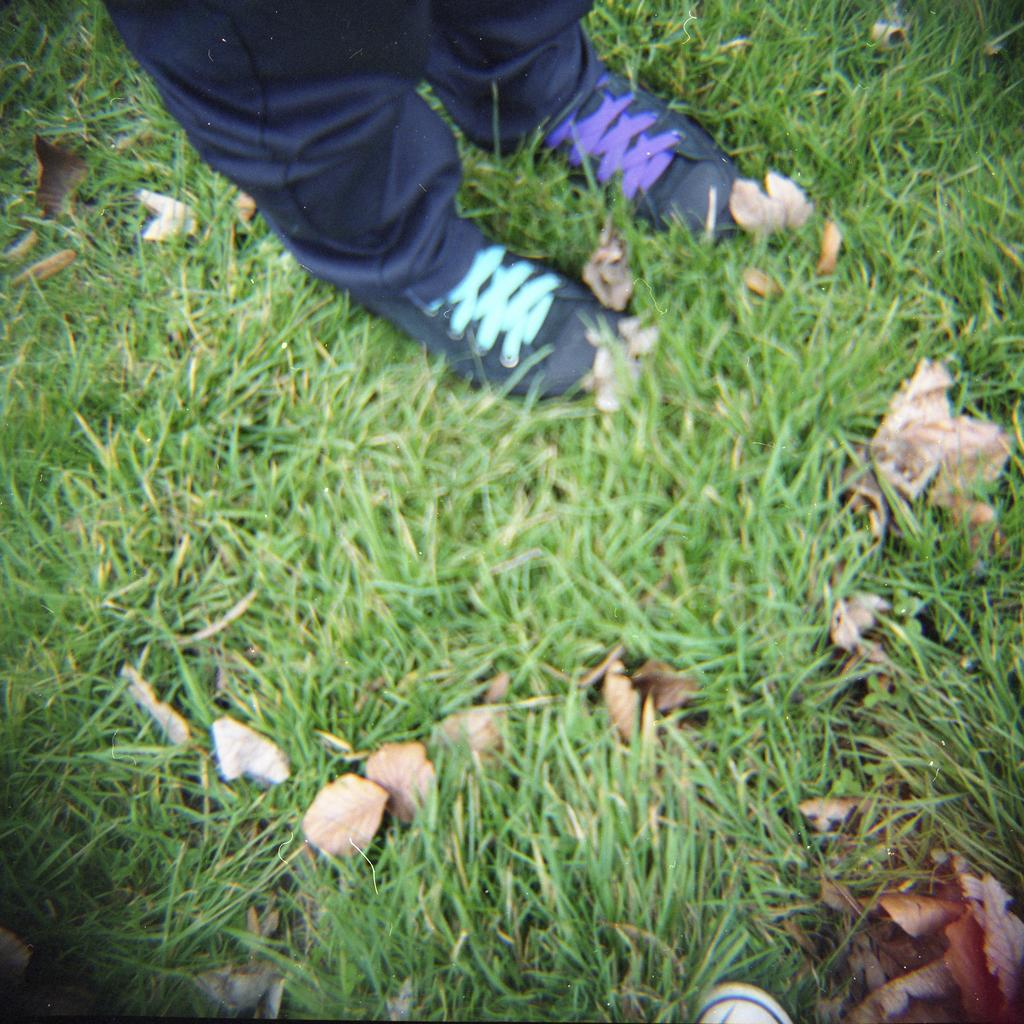What type of vegetation is present in the image? There is grass in the image. What is on top of the grass? There are dried leaves on the grass. Whose legs can be seen in the image? A: There are person's legs visible towards the top of the image. What object can be found towards the bottom of the image? There is an object towards the bottom of the image. What type of receipt can be seen in the image? There is no receipt present in the image. How many daughters are visible in the image? There is no daughter present in the image. 